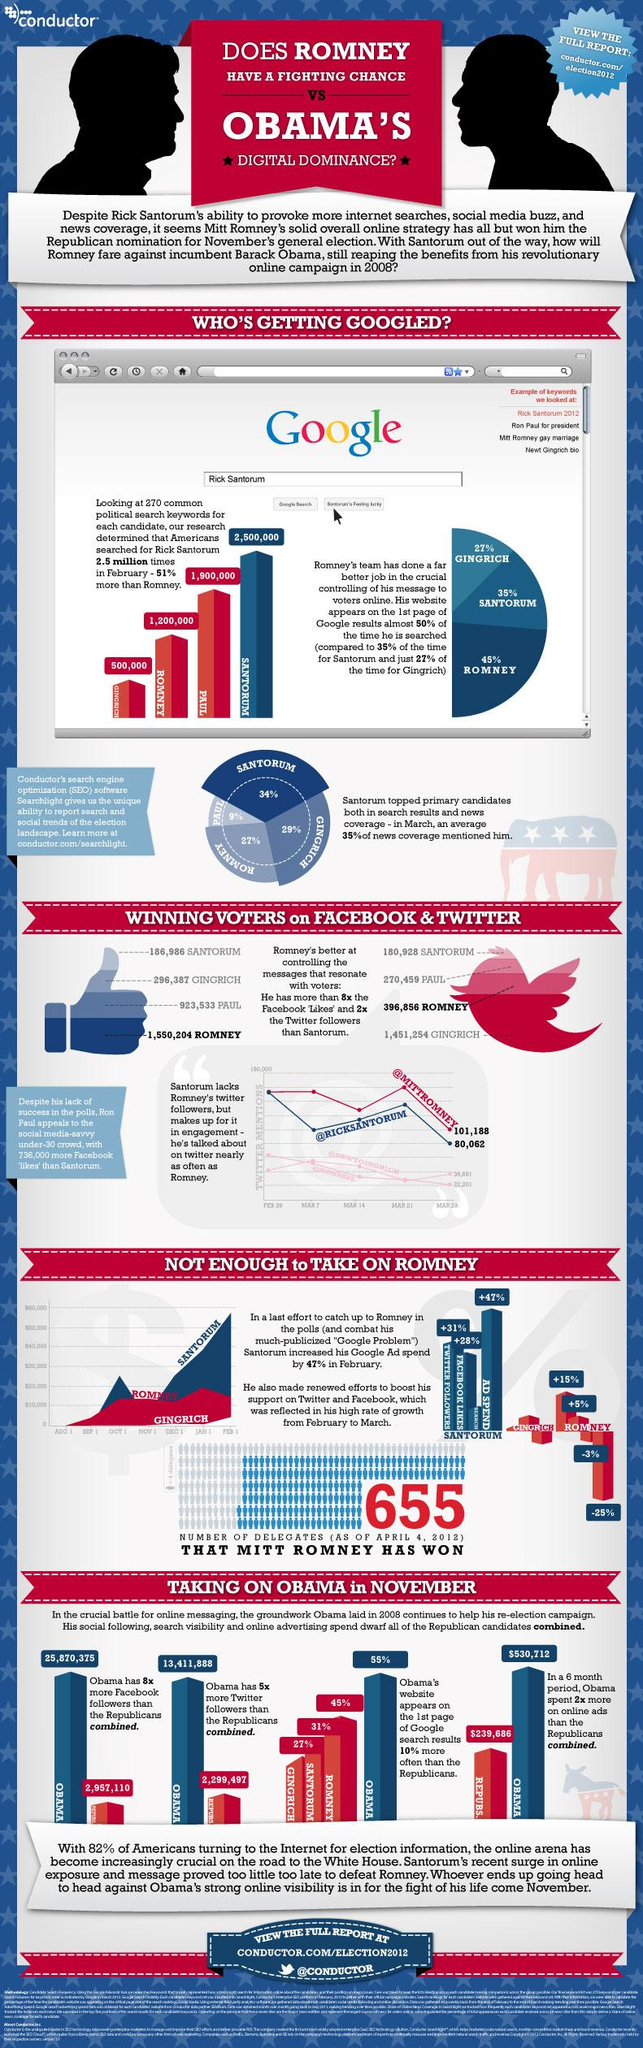Point out several critical features in this image. Rick Santorum appeared as a keyword significantly fewer times than Newt Gingrich in the given range. During February and March of the election year, Romney's ad spend was approximately -25% lower compared to the previous month. The second lowest number of voters through Facebook was 296,387. The number of voters through Twitter who cast their votes was 270,459. In the year 2012, Mitt Romney spent $20,000 on advertising on January 1st. 